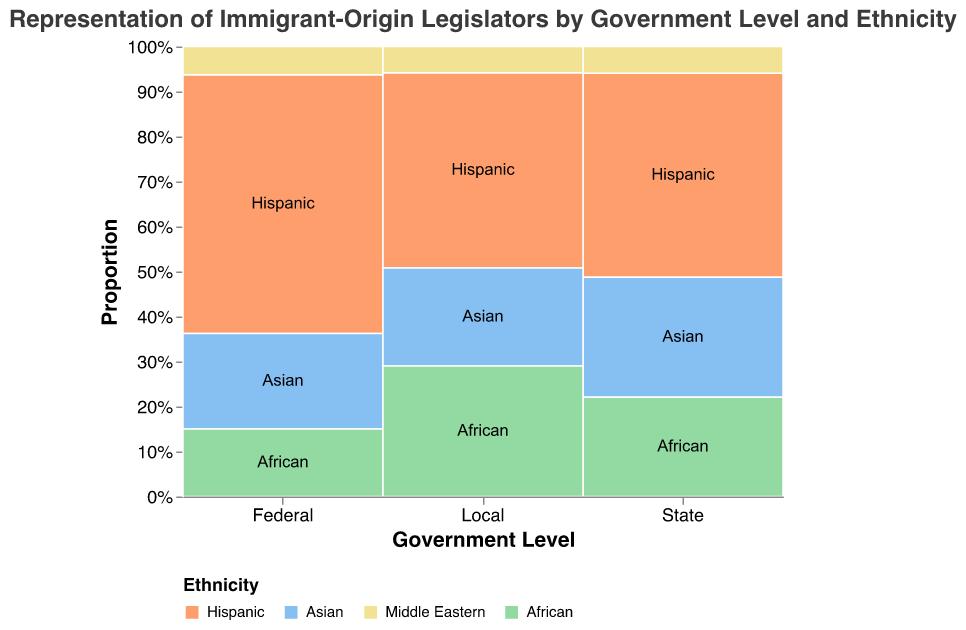How many Hispanic immigrant-origin legislators are there in total across all government levels? To find the number of Hispanic immigrant-origin legislators in total, sum up the number of Hispanic legislators at each government level: 46 (Federal) + 321 (State) + 2145 (Local). The total number is 2512
Answer: 2512 At the federal level, which ethnicity has the least number of immigrant-origin legislators? At the federal level, the number of immigrant-origin legislators for each ethnicity are: Hispanic (46), Asian (17), Middle Eastern (5), and African (12). So, Middle Eastern has the least number with 5 legislators.
Answer: Middle Eastern How does the proportion of Asian legislators compare between state and local government levels? The proportions of Asian immigrant-origin legislators are visible in the mosaic plot: State level shows a significant proportion, while Local level shows a smaller but still sizable proportion. By totaling the number of legislators at each level and calculating the percentage, we see Asians have a higher proportion at the State level than at the Local level.
Answer: State more than Local Which government level has the highest representation of African immigrant-origin legislators in absolute numbers? Looking at the number of African immigrant-origin legislators: Federal (12), State (156), and Local (1432). The Local level has the highest representation with 1432 African legislators.
Answer: Local What is the combined proportion of Middle Eastern immigrant-origin legislators at the State and Local levels? First, identify the number of Middle Eastern legislators at the State (42) and Local (287) levels. Then calculate the combined sum and compare it with the total number of legislators at these levels. The calculated combined proportion shows their total representation.
Answer: Relatively Low How does the proportion of immigrant-origin legislators from the Hispanic ethnicity compare across the three levels of government? By examining the mosaic plot, we can see that the proportion of Hispanic legislators is highest at the Local level, followed by the State level, and is the least at the Federal level. The plot clearly indicates higher Hispanic representation in more localized forms of government.
Answer: Local > State > Federal What fraction of total immigrant-origin legislators at the Federal level are Hispanic? The total number of immigrant-origin legislators at the Federal level can be found by summing the number of legislators for all ethnicities (46 Hispanic + 17 Asian + 5 Middle Eastern + 12 African = 80). The fraction for Hispanic would then be 46/80.
Answer: 46/80 or 57.5% Which ethnicity has the most balanced distribution across all government levels? By comparing the proportions for each ethnicity across the Federal, State, and Local levels in the mosaic plot, a balanced distribution would mean similar proportion sizes. Hispanic and African show higher proportions locally but less so federally. Asian and Middle Eastern distributions need to be checked for less variance.
Answer: Asian or Middle Eastern (least variation) 